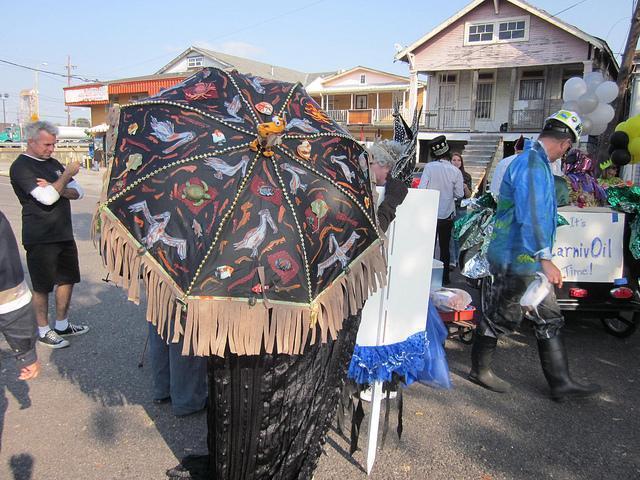How many people are holding umbrellas?
Give a very brief answer. 1. How many people can be seen?
Give a very brief answer. 5. How many elephants are there?
Give a very brief answer. 0. 